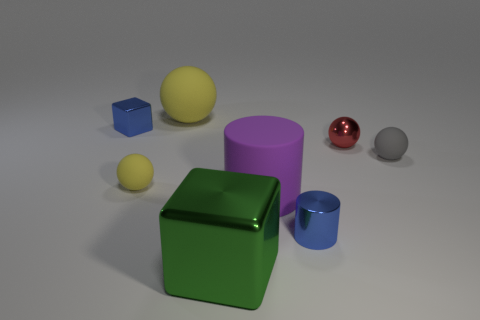Is the color of the metallic cylinder the same as the tiny metallic block?
Your response must be concise. Yes. There is a small ball that is to the left of the small shiny ball; does it have the same color as the big sphere?
Provide a succinct answer. Yes. Is the color of the big sphere the same as the tiny matte object that is left of the green shiny block?
Offer a terse response. Yes. How many tiny things have the same color as the tiny block?
Provide a succinct answer. 1. Do the large rubber object behind the matte cylinder and the tiny matte thing to the left of the large purple object have the same color?
Provide a succinct answer. Yes. What is the material of the gray ball?
Your answer should be very brief. Rubber. How many other objects are the same shape as the red metal thing?
Your answer should be very brief. 3. Do the big yellow object and the small gray thing have the same shape?
Provide a succinct answer. Yes. How many objects are either rubber objects that are to the right of the small blue metallic cylinder or tiny matte balls that are right of the big metal cube?
Ensure brevity in your answer.  1. How many things are tiny red spheres or gray spheres?
Your answer should be compact. 2. 